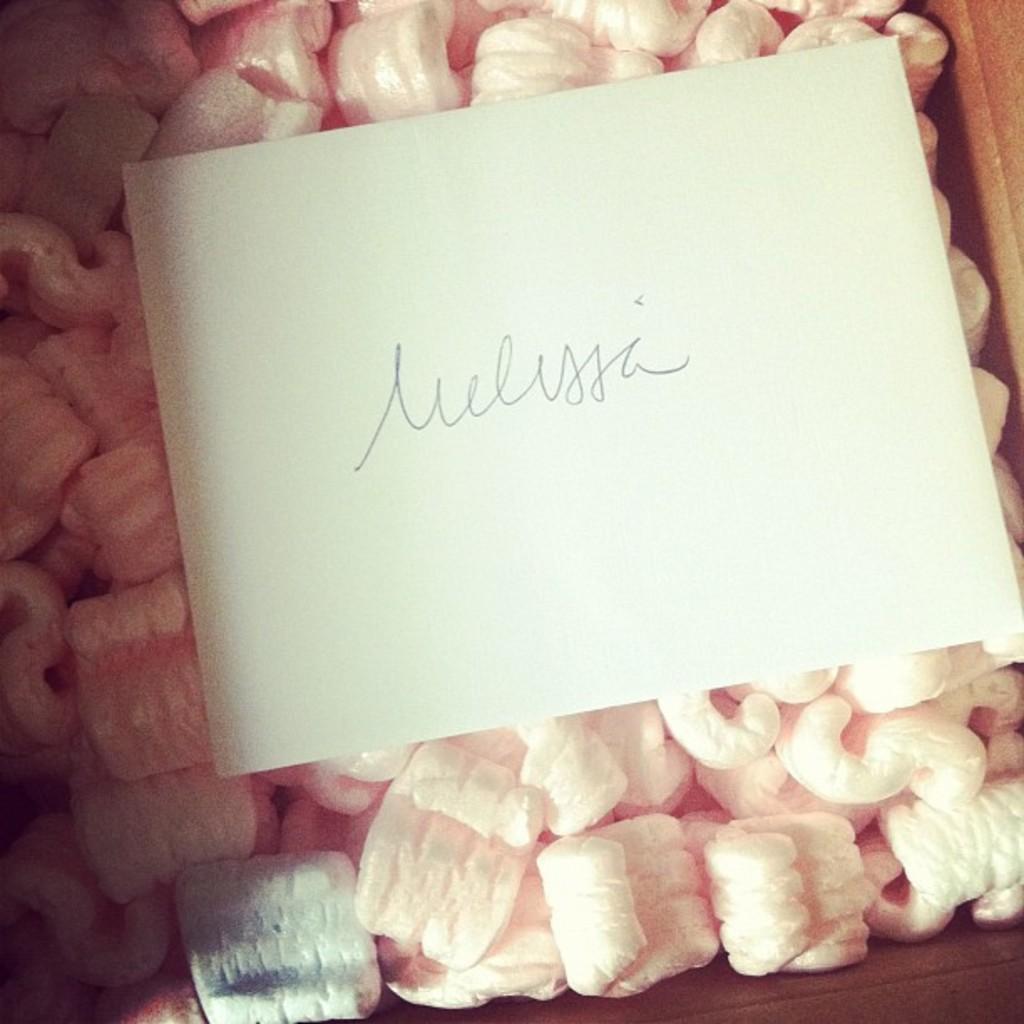In one or two sentences, can you explain what this image depicts? In this picture we can see a paper, there is some text on this paper, they are looking like marshmallows at the bottom. 